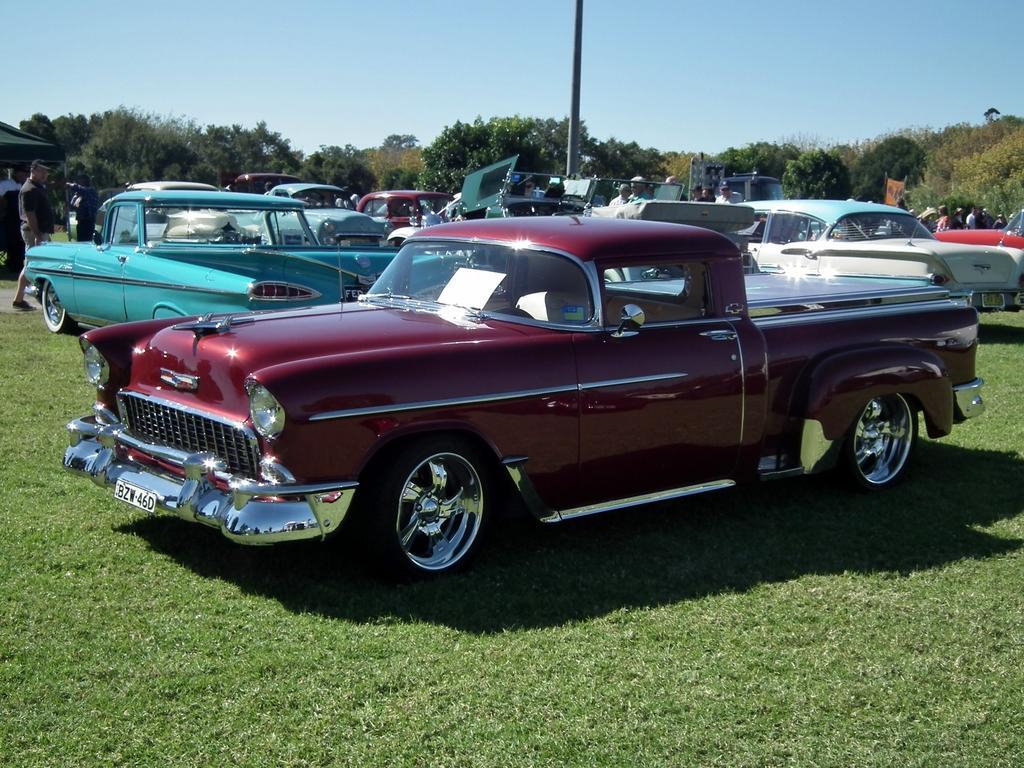Please provide a concise description of this image. This picture is clicked outside. In the foreground we can see the green grass. In the center we can see the cars parked on the ground and we can see the group of people and a pole. In the left corner we can see the tent and some objects. In the background we can see the sky, trees and a vehicle and the group of people. 